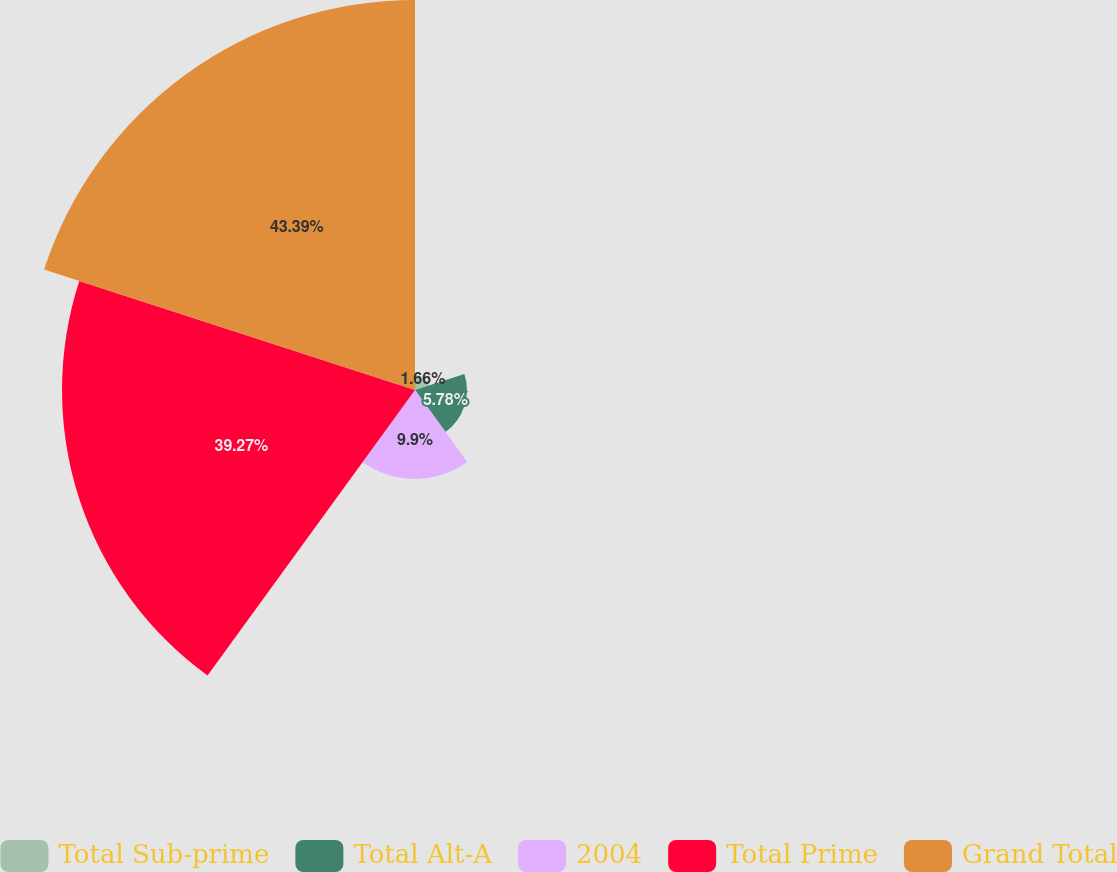<chart> <loc_0><loc_0><loc_500><loc_500><pie_chart><fcel>Total Sub-prime<fcel>Total Alt-A<fcel>2004<fcel>Total Prime<fcel>Grand Total<nl><fcel>1.66%<fcel>5.78%<fcel>9.9%<fcel>39.28%<fcel>43.4%<nl></chart> 